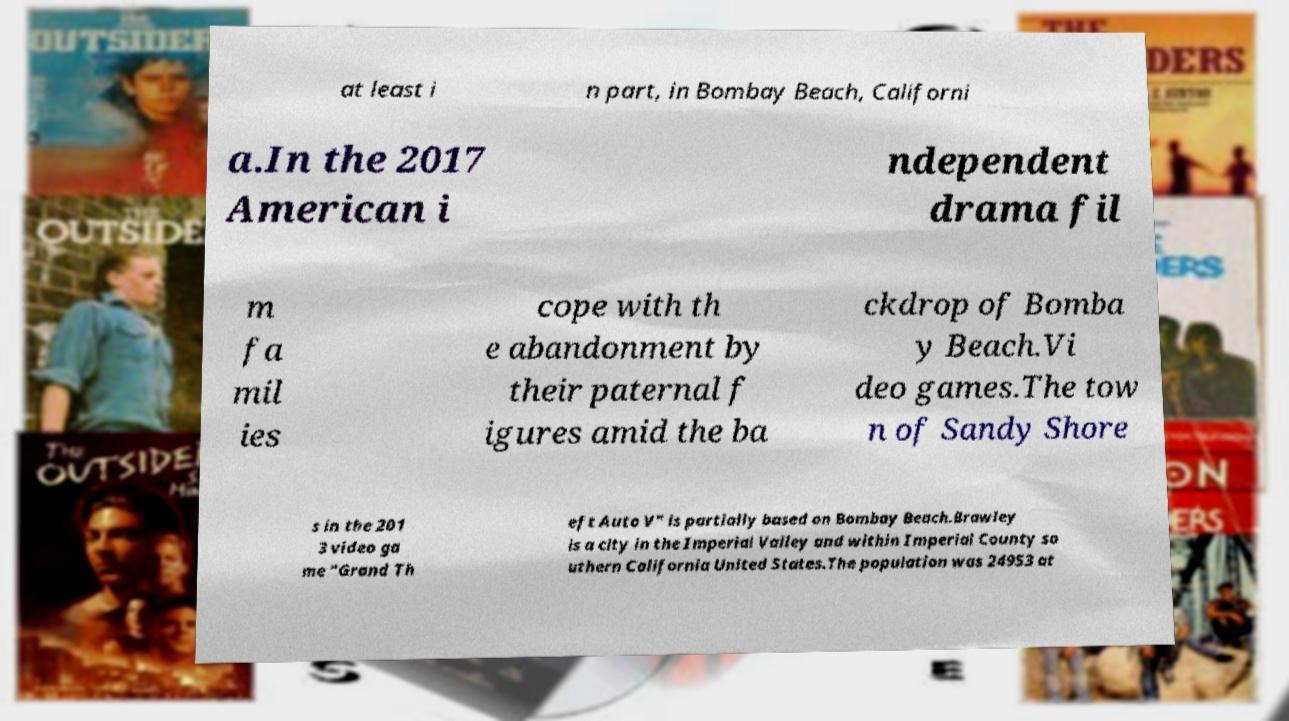Can you accurately transcribe the text from the provided image for me? at least i n part, in Bombay Beach, Californi a.In the 2017 American i ndependent drama fil m fa mil ies cope with th e abandonment by their paternal f igures amid the ba ckdrop of Bomba y Beach.Vi deo games.The tow n of Sandy Shore s in the 201 3 video ga me "Grand Th eft Auto V" is partially based on Bombay Beach.Brawley is a city in the Imperial Valley and within Imperial County so uthern California United States.The population was 24953 at 